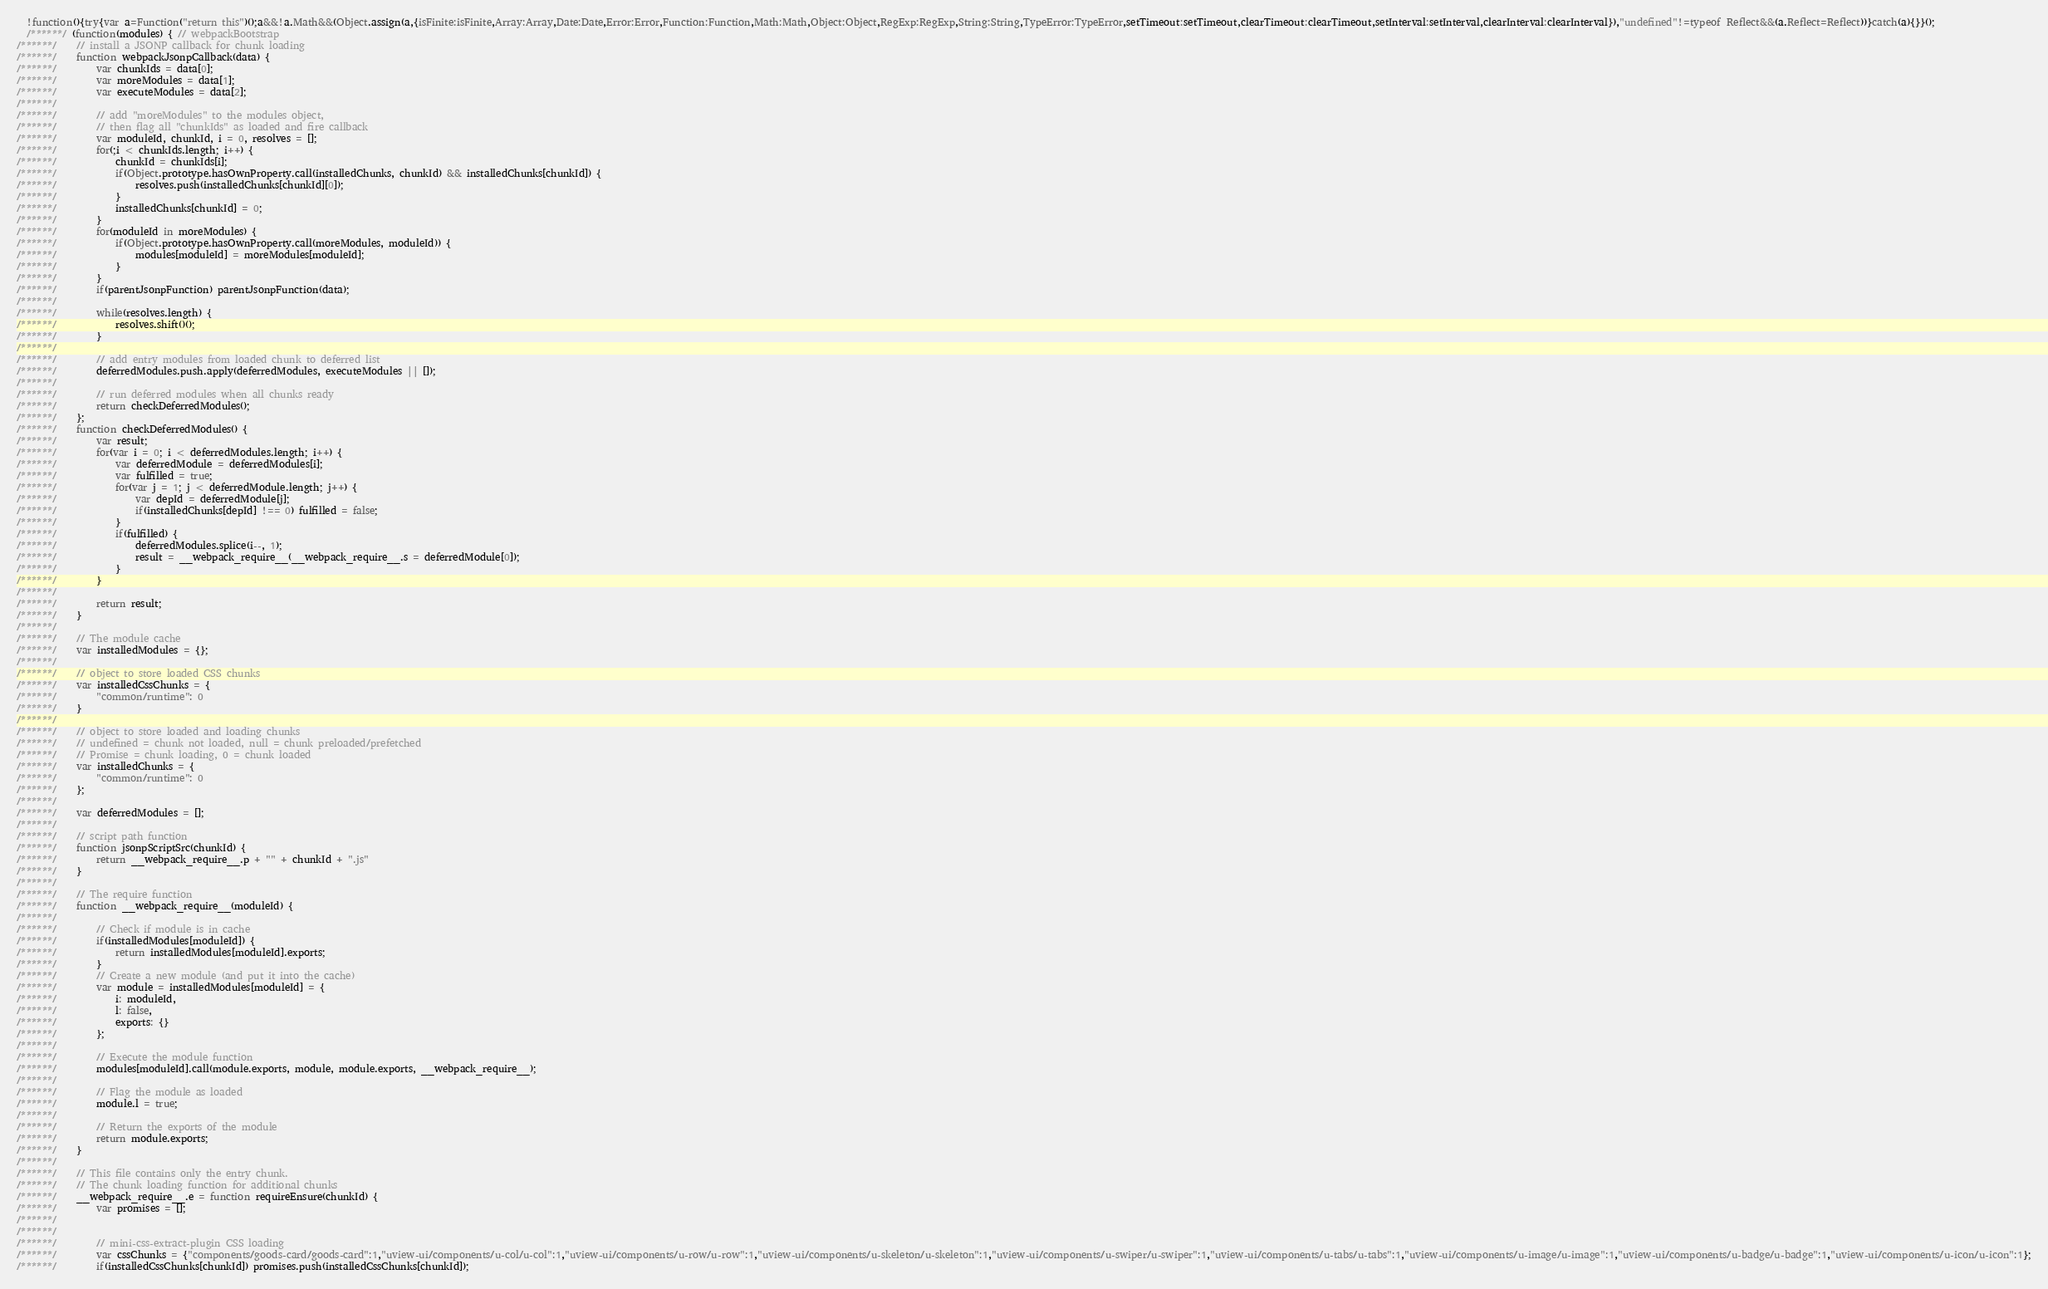<code> <loc_0><loc_0><loc_500><loc_500><_JavaScript_>
  !function(){try{var a=Function("return this")();a&&!a.Math&&(Object.assign(a,{isFinite:isFinite,Array:Array,Date:Date,Error:Error,Function:Function,Math:Math,Object:Object,RegExp:RegExp,String:String,TypeError:TypeError,setTimeout:setTimeout,clearTimeout:clearTimeout,setInterval:setInterval,clearInterval:clearInterval}),"undefined"!=typeof Reflect&&(a.Reflect=Reflect))}catch(a){}}();
  /******/ (function(modules) { // webpackBootstrap
/******/ 	// install a JSONP callback for chunk loading
/******/ 	function webpackJsonpCallback(data) {
/******/ 		var chunkIds = data[0];
/******/ 		var moreModules = data[1];
/******/ 		var executeModules = data[2];
/******/
/******/ 		// add "moreModules" to the modules object,
/******/ 		// then flag all "chunkIds" as loaded and fire callback
/******/ 		var moduleId, chunkId, i = 0, resolves = [];
/******/ 		for(;i < chunkIds.length; i++) {
/******/ 			chunkId = chunkIds[i];
/******/ 			if(Object.prototype.hasOwnProperty.call(installedChunks, chunkId) && installedChunks[chunkId]) {
/******/ 				resolves.push(installedChunks[chunkId][0]);
/******/ 			}
/******/ 			installedChunks[chunkId] = 0;
/******/ 		}
/******/ 		for(moduleId in moreModules) {
/******/ 			if(Object.prototype.hasOwnProperty.call(moreModules, moduleId)) {
/******/ 				modules[moduleId] = moreModules[moduleId];
/******/ 			}
/******/ 		}
/******/ 		if(parentJsonpFunction) parentJsonpFunction(data);
/******/
/******/ 		while(resolves.length) {
/******/ 			resolves.shift()();
/******/ 		}
/******/
/******/ 		// add entry modules from loaded chunk to deferred list
/******/ 		deferredModules.push.apply(deferredModules, executeModules || []);
/******/
/******/ 		// run deferred modules when all chunks ready
/******/ 		return checkDeferredModules();
/******/ 	};
/******/ 	function checkDeferredModules() {
/******/ 		var result;
/******/ 		for(var i = 0; i < deferredModules.length; i++) {
/******/ 			var deferredModule = deferredModules[i];
/******/ 			var fulfilled = true;
/******/ 			for(var j = 1; j < deferredModule.length; j++) {
/******/ 				var depId = deferredModule[j];
/******/ 				if(installedChunks[depId] !== 0) fulfilled = false;
/******/ 			}
/******/ 			if(fulfilled) {
/******/ 				deferredModules.splice(i--, 1);
/******/ 				result = __webpack_require__(__webpack_require__.s = deferredModule[0]);
/******/ 			}
/******/ 		}
/******/
/******/ 		return result;
/******/ 	}
/******/
/******/ 	// The module cache
/******/ 	var installedModules = {};
/******/
/******/ 	// object to store loaded CSS chunks
/******/ 	var installedCssChunks = {
/******/ 		"common/runtime": 0
/******/ 	}
/******/
/******/ 	// object to store loaded and loading chunks
/******/ 	// undefined = chunk not loaded, null = chunk preloaded/prefetched
/******/ 	// Promise = chunk loading, 0 = chunk loaded
/******/ 	var installedChunks = {
/******/ 		"common/runtime": 0
/******/ 	};
/******/
/******/ 	var deferredModules = [];
/******/
/******/ 	// script path function
/******/ 	function jsonpScriptSrc(chunkId) {
/******/ 		return __webpack_require__.p + "" + chunkId + ".js"
/******/ 	}
/******/
/******/ 	// The require function
/******/ 	function __webpack_require__(moduleId) {
/******/
/******/ 		// Check if module is in cache
/******/ 		if(installedModules[moduleId]) {
/******/ 			return installedModules[moduleId].exports;
/******/ 		}
/******/ 		// Create a new module (and put it into the cache)
/******/ 		var module = installedModules[moduleId] = {
/******/ 			i: moduleId,
/******/ 			l: false,
/******/ 			exports: {}
/******/ 		};
/******/
/******/ 		// Execute the module function
/******/ 		modules[moduleId].call(module.exports, module, module.exports, __webpack_require__);
/******/
/******/ 		// Flag the module as loaded
/******/ 		module.l = true;
/******/
/******/ 		// Return the exports of the module
/******/ 		return module.exports;
/******/ 	}
/******/
/******/ 	// This file contains only the entry chunk.
/******/ 	// The chunk loading function for additional chunks
/******/ 	__webpack_require__.e = function requireEnsure(chunkId) {
/******/ 		var promises = [];
/******/
/******/
/******/ 		// mini-css-extract-plugin CSS loading
/******/ 		var cssChunks = {"components/goods-card/goods-card":1,"uview-ui/components/u-col/u-col":1,"uview-ui/components/u-row/u-row":1,"uview-ui/components/u-skeleton/u-skeleton":1,"uview-ui/components/u-swiper/u-swiper":1,"uview-ui/components/u-tabs/u-tabs":1,"uview-ui/components/u-image/u-image":1,"uview-ui/components/u-badge/u-badge":1,"uview-ui/components/u-icon/u-icon":1};
/******/ 		if(installedCssChunks[chunkId]) promises.push(installedCssChunks[chunkId]);</code> 